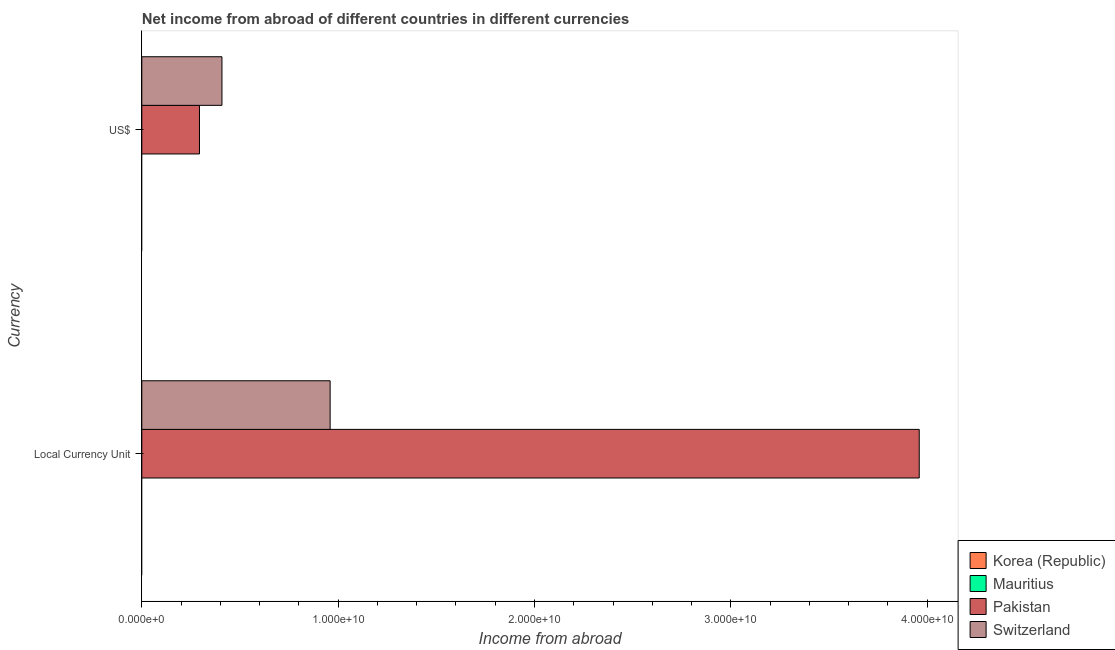How many different coloured bars are there?
Your answer should be compact. 2. Are the number of bars per tick equal to the number of legend labels?
Offer a terse response. No. How many bars are there on the 2nd tick from the top?
Offer a very short reply. 2. What is the label of the 1st group of bars from the top?
Make the answer very short. US$. What is the income from abroad in constant 2005 us$ in Mauritius?
Provide a short and direct response. 0. Across all countries, what is the maximum income from abroad in constant 2005 us$?
Offer a very short reply. 3.96e+1. What is the total income from abroad in us$ in the graph?
Your answer should be very brief. 7.02e+09. What is the difference between the income from abroad in us$ in Switzerland and that in Pakistan?
Give a very brief answer. 1.14e+09. What is the average income from abroad in constant 2005 us$ per country?
Offer a terse response. 1.23e+1. What is the difference between the income from abroad in constant 2005 us$ and income from abroad in us$ in Pakistan?
Give a very brief answer. 3.67e+1. What is the ratio of the income from abroad in us$ in Pakistan to that in Switzerland?
Offer a very short reply. 0.72. Is the income from abroad in constant 2005 us$ in Pakistan less than that in Switzerland?
Keep it short and to the point. No. In how many countries, is the income from abroad in constant 2005 us$ greater than the average income from abroad in constant 2005 us$ taken over all countries?
Give a very brief answer. 1. How many bars are there?
Your answer should be very brief. 4. Are all the bars in the graph horizontal?
Offer a terse response. Yes. Does the graph contain any zero values?
Your answer should be very brief. Yes. Does the graph contain grids?
Offer a terse response. No. Where does the legend appear in the graph?
Your answer should be compact. Bottom right. How many legend labels are there?
Your response must be concise. 4. What is the title of the graph?
Provide a short and direct response. Net income from abroad of different countries in different currencies. Does "Hong Kong" appear as one of the legend labels in the graph?
Offer a terse response. No. What is the label or title of the X-axis?
Provide a succinct answer. Income from abroad. What is the label or title of the Y-axis?
Provide a succinct answer. Currency. What is the Income from abroad of Pakistan in Local Currency Unit?
Offer a terse response. 3.96e+1. What is the Income from abroad in Switzerland in Local Currency Unit?
Provide a short and direct response. 9.59e+09. What is the Income from abroad in Korea (Republic) in US$?
Your answer should be very brief. 0. What is the Income from abroad in Pakistan in US$?
Offer a very short reply. 2.94e+09. What is the Income from abroad in Switzerland in US$?
Keep it short and to the point. 4.08e+09. Across all Currency, what is the maximum Income from abroad of Pakistan?
Give a very brief answer. 3.96e+1. Across all Currency, what is the maximum Income from abroad of Switzerland?
Your answer should be compact. 9.59e+09. Across all Currency, what is the minimum Income from abroad in Pakistan?
Give a very brief answer. 2.94e+09. Across all Currency, what is the minimum Income from abroad of Switzerland?
Make the answer very short. 4.08e+09. What is the total Income from abroad in Pakistan in the graph?
Give a very brief answer. 4.25e+1. What is the total Income from abroad in Switzerland in the graph?
Ensure brevity in your answer.  1.37e+1. What is the difference between the Income from abroad of Pakistan in Local Currency Unit and that in US$?
Ensure brevity in your answer.  3.67e+1. What is the difference between the Income from abroad of Switzerland in Local Currency Unit and that in US$?
Your answer should be compact. 5.51e+09. What is the difference between the Income from abroad in Pakistan in Local Currency Unit and the Income from abroad in Switzerland in US$?
Your answer should be very brief. 3.55e+1. What is the average Income from abroad in Mauritius per Currency?
Keep it short and to the point. 0. What is the average Income from abroad in Pakistan per Currency?
Provide a succinct answer. 2.13e+1. What is the average Income from abroad in Switzerland per Currency?
Provide a succinct answer. 6.84e+09. What is the difference between the Income from abroad in Pakistan and Income from abroad in Switzerland in Local Currency Unit?
Keep it short and to the point. 3.00e+1. What is the difference between the Income from abroad of Pakistan and Income from abroad of Switzerland in US$?
Offer a very short reply. -1.14e+09. What is the ratio of the Income from abroad in Pakistan in Local Currency Unit to that in US$?
Offer a very short reply. 13.48. What is the ratio of the Income from abroad of Switzerland in Local Currency Unit to that in US$?
Your answer should be very brief. 2.35. What is the difference between the highest and the second highest Income from abroad of Pakistan?
Your answer should be compact. 3.67e+1. What is the difference between the highest and the second highest Income from abroad of Switzerland?
Keep it short and to the point. 5.51e+09. What is the difference between the highest and the lowest Income from abroad in Pakistan?
Your response must be concise. 3.67e+1. What is the difference between the highest and the lowest Income from abroad in Switzerland?
Provide a short and direct response. 5.51e+09. 